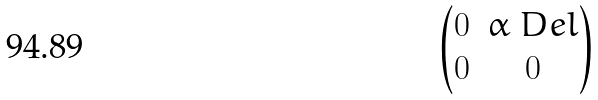<formula> <loc_0><loc_0><loc_500><loc_500>\begin{pmatrix} 0 & \alpha _ { \ } D e l \\ 0 & 0 \end{pmatrix}</formula> 